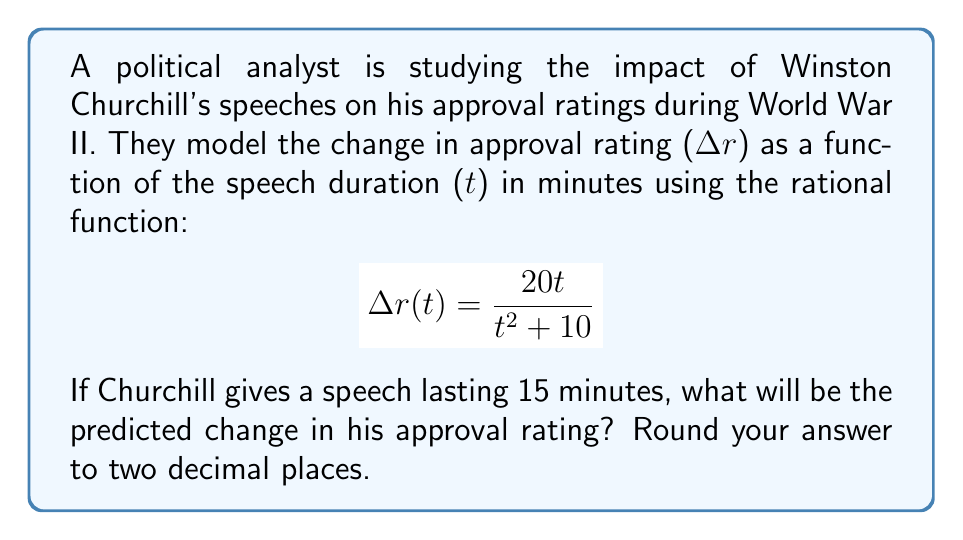What is the answer to this math problem? To solve this problem, we'll follow these steps:

1) We're given the rational function for the change in approval rating:
   $$\Delta r(t) = \frac{20t}{t^2 + 10}$$

2) We need to find Δr(15), as the speech lasts 15 minutes:
   $$\Delta r(15) = \frac{20(15)}{15^2 + 10}$$

3) Let's simplify the numerator:
   $$\Delta r(15) = \frac{300}{15^2 + 10}$$

4) Now, let's calculate the denominator:
   $15^2 = 225$
   $225 + 10 = 235$

5) So our equation becomes:
   $$\Delta r(15) = \frac{300}{235}$$

6) Dividing 300 by 235:
   $$\Delta r(15) \approx 1.2765957447$$

7) Rounding to two decimal places:
   $$\Delta r(15) \approx 1.28$$

Therefore, the predicted change in Churchill's approval rating after a 15-minute speech is approximately 1.28 points.
Answer: 1.28 